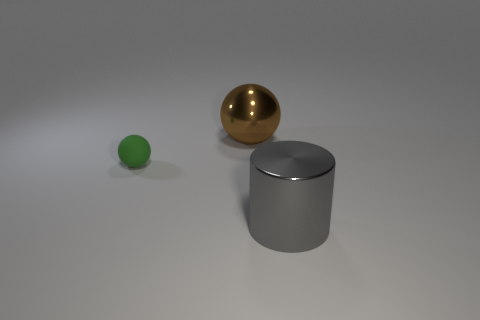There is another brown thing that is the same shape as the tiny object; what size is it?
Your response must be concise. Large. What number of cyan things are either cylinders or rubber balls?
Offer a terse response. 0. There is a metallic thing that is left of the big cylinder; what number of balls are behind it?
Give a very brief answer. 0. What number of other things are there of the same shape as the gray metallic thing?
Keep it short and to the point. 0. What number of other spheres have the same color as the metal sphere?
Make the answer very short. 0. There is another large thing that is the same material as the brown object; what is its color?
Give a very brief answer. Gray. Are there any metallic objects that have the same size as the brown metallic sphere?
Your answer should be very brief. Yes. Are there more big gray shiny cylinders that are to the right of the gray cylinder than green objects that are behind the brown metal sphere?
Provide a short and direct response. No. Is the big object in front of the brown ball made of the same material as the ball that is in front of the brown shiny object?
Offer a terse response. No. What is the shape of the gray shiny object that is the same size as the brown shiny thing?
Give a very brief answer. Cylinder. 